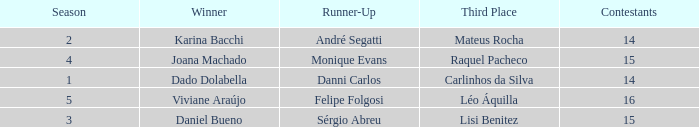How many contestants were there when the runner-up was Sérgio Abreu?  15.0. 